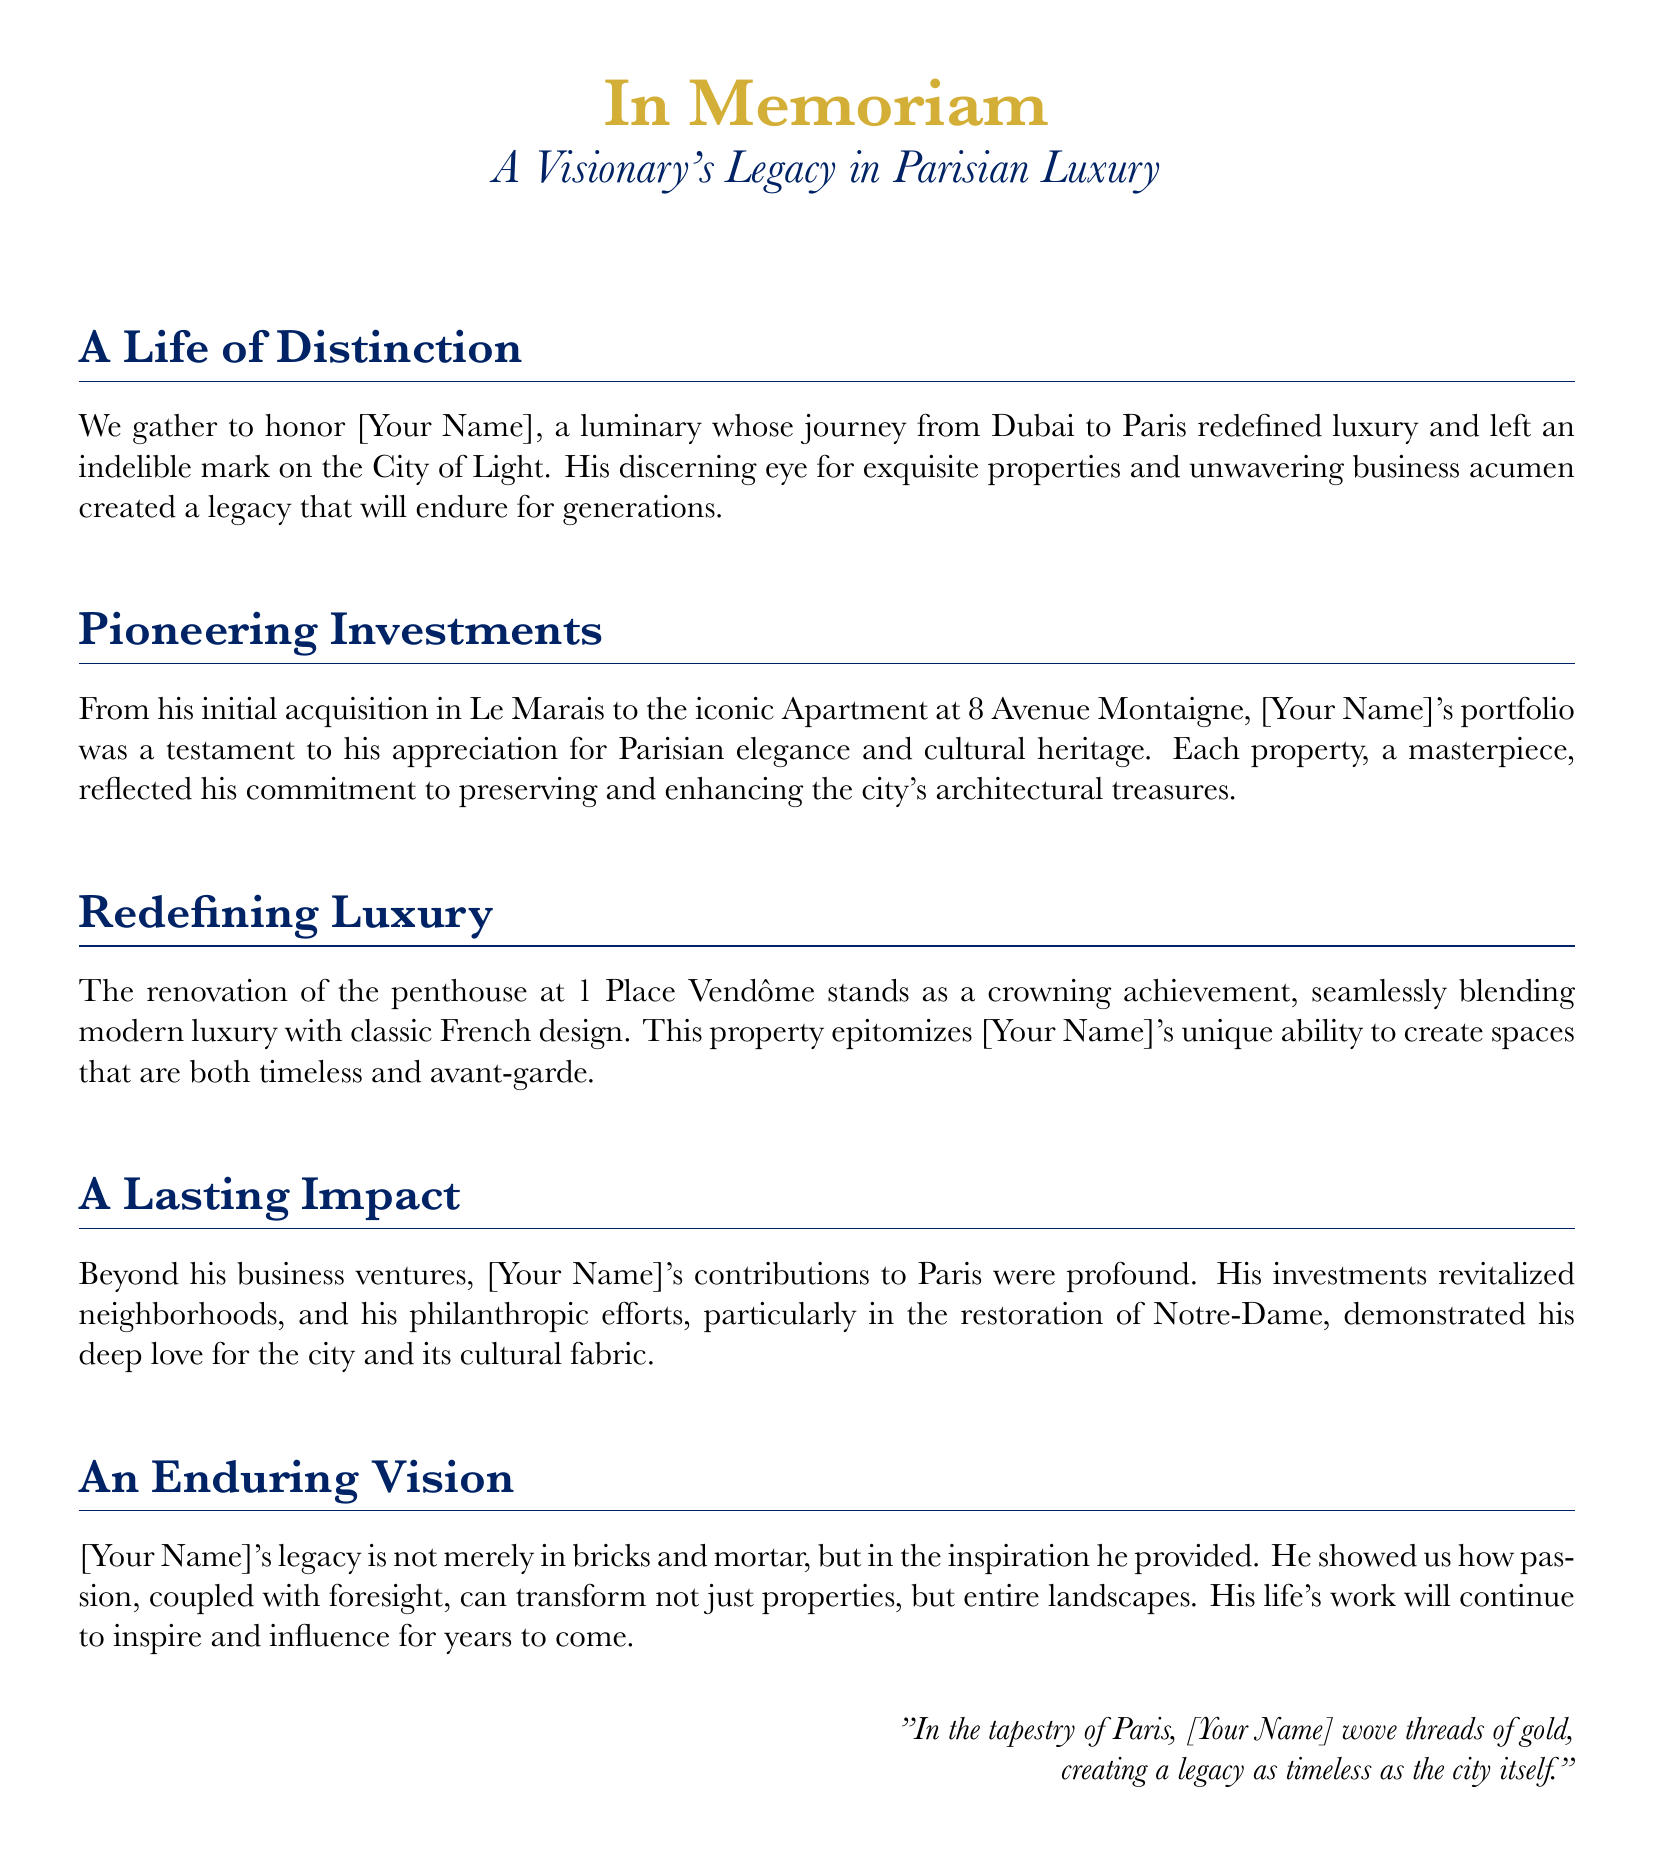What is the name mentioned in the eulogy? The eulogy honors [Your Name], who is referenced throughout the document.
Answer: [Your Name] What iconic address is associated with a specific property? The eulogy mentions the iconic Apartment at 8 Avenue Montaigne as part of [Your Name]'s portfolio.
Answer: 8 Avenue Montaigne What is noted as a crowning achievement in the document? The eulogy describes the renovation of the penthouse at 1 Place Vendôme as a significant accomplishment.
Answer: Penthouse at 1 Place Vendôme Which neighborhood did [Your Name] initially invest in? The initial acquisition mentioned in the eulogy is located in Le Marais.
Answer: Le Marais What type of contributions did [Your Name] make to Paris apart from business? The eulogy highlights [Your Name]'s philanthropic efforts, particularly in cultural restoration, as significant contributions.
Answer: Philanthropic efforts In which project did [Your Name] demonstrate a commitment to restoration? The mention of contributions to the restoration of Notre-Dame illustrates a commitment to cultural preservation.
Answer: Notre-Dame What is emphasized about [Your Name]'s investments in neighborhoods? The eulogy states that [Your Name]'s investments revitalized neighborhoods in Paris.
Answer: Revitalized neighborhoods How does the eulogy describe [Your Name]'s influence on the city's landscape? The document states [Your Name]'s life's work will continue to inspire and influence for years to come, affecting the city's landscape.
Answer: Inspire and influence What is the essence of [Your Name]'s legacy according to the eulogy? The eulogy reflects that [Your Name]'s legacy is intertwined with both physical properties and inspirational vision.
Answer: Inspiration and properties 